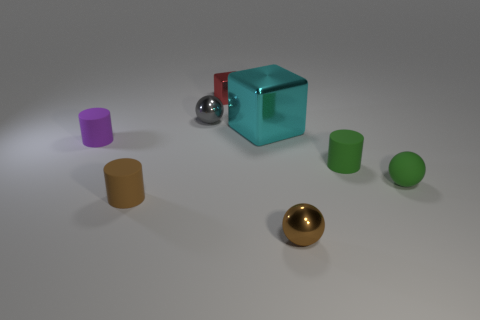How many things are red metal things or small spheres in front of the large cyan metal thing?
Offer a terse response. 3. Are there any other large things that have the same color as the large metallic object?
Your answer should be very brief. No. What number of green things are small rubber objects or rubber spheres?
Your response must be concise. 2. How many other objects are the same size as the brown metallic thing?
Ensure brevity in your answer.  6. What number of tiny things are either rubber spheres or green matte cylinders?
Your answer should be very brief. 2. There is a matte sphere; is its size the same as the cyan metal object that is in front of the small red metal cube?
Your answer should be compact. No. What number of other objects are the same shape as the small gray metal thing?
Make the answer very short. 2. The brown object that is made of the same material as the cyan object is what shape?
Provide a succinct answer. Sphere. Is there a brown cylinder?
Keep it short and to the point. Yes. Are there fewer small brown cylinders that are in front of the brown rubber thing than gray shiny spheres behind the cyan thing?
Make the answer very short. Yes. 